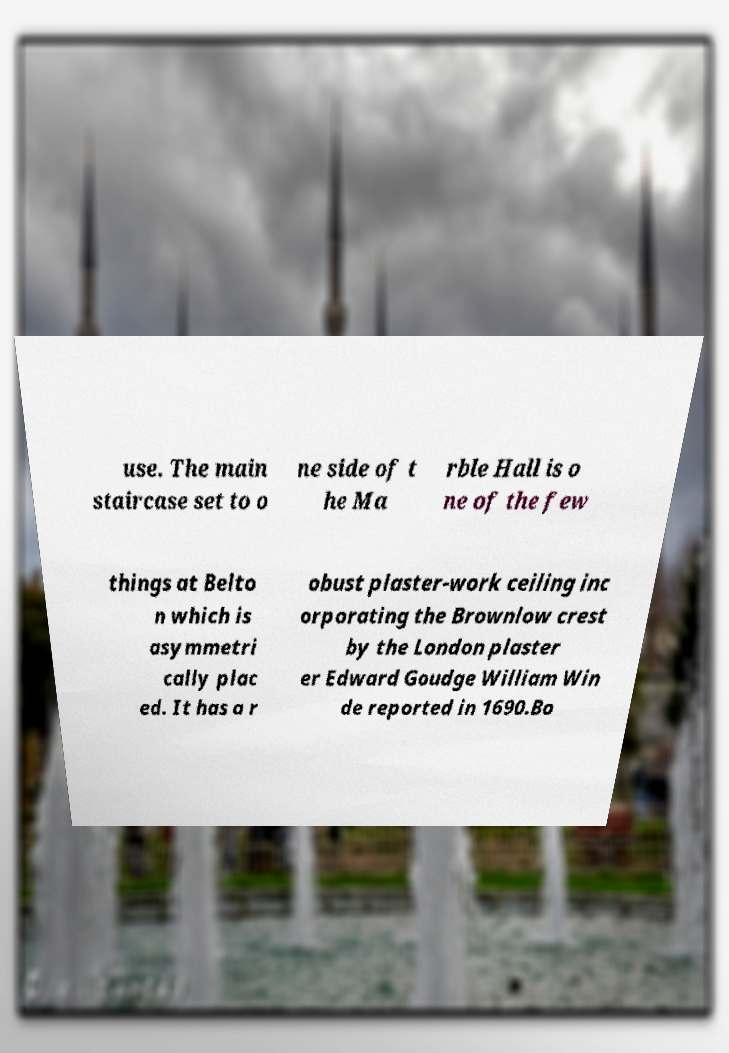Can you accurately transcribe the text from the provided image for me? use. The main staircase set to o ne side of t he Ma rble Hall is o ne of the few things at Belto n which is asymmetri cally plac ed. It has a r obust plaster-work ceiling inc orporating the Brownlow crest by the London plaster er Edward Goudge William Win de reported in 1690.Bo 